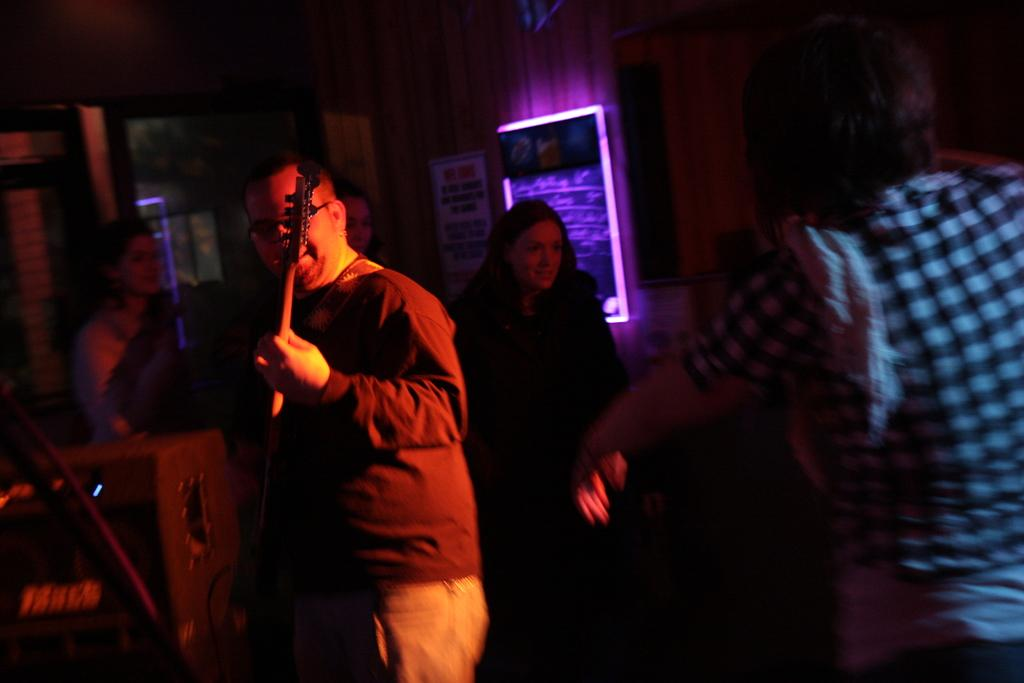What is the man in the image doing? The man is playing a guitar in the image. Are there any other people present in the image? Yes, there are people standing in the image. What can be seen on the wall in the image? There is a poster on the wall in the image. Can you describe the board with lighting in the image? There is a board with lighting in the image, but the specific details of the board are not mentioned in the provided facts. What type of tax is being discussed by the people in the image? There is no mention of a tax or any discussion about taxes in the image. Can you see a car in the image? There is no car present in the image. Are there any ducks visible in the image? There is no mention of ducks in the image. 